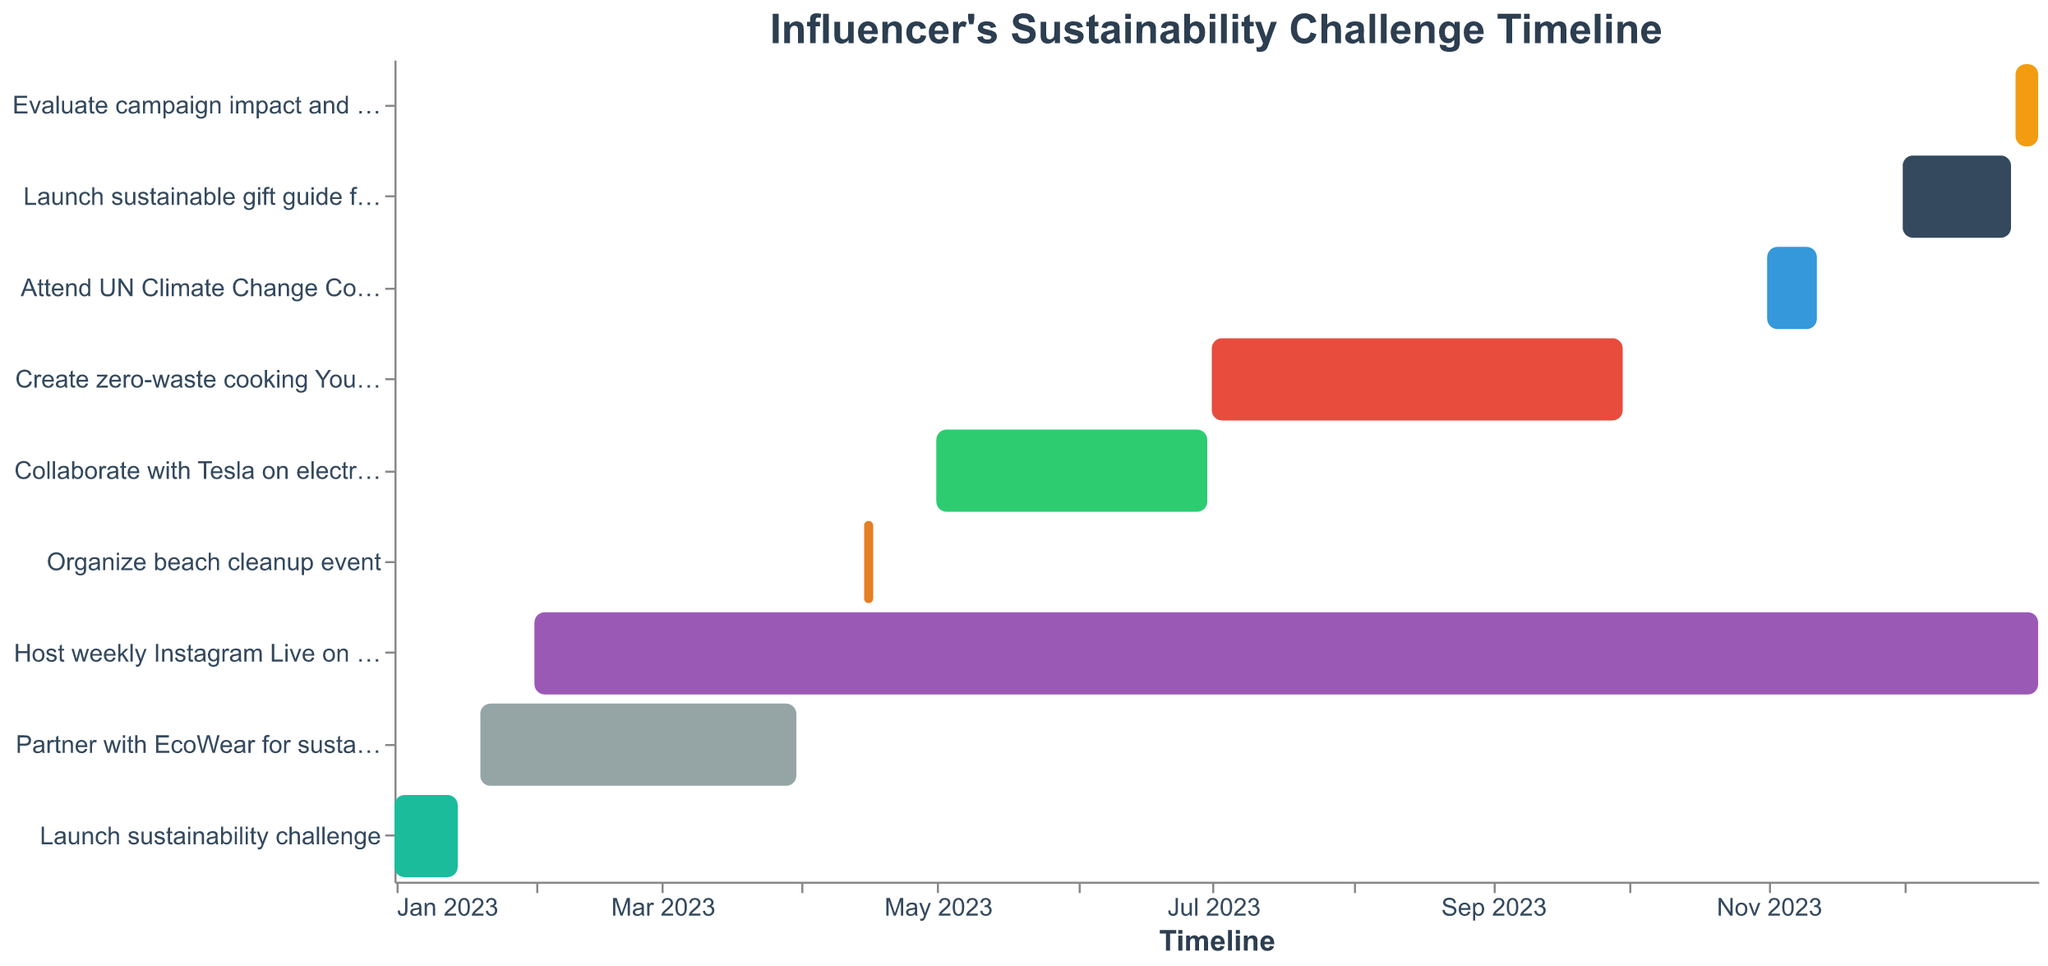What's the title of the Gantt Chart? The title is displayed at the top of the chart.
Answer: Influencer's Sustainability Challenge Timeline What is the duration for the partnership with EcoWear? The partnership with EcoWear starts on January 20, 2023, and ends on March 31, 2023.
Answer: 71 days Which task spans the longest duration? By comparing the start and end dates, the "Host weekly Instagram Live on eco-friendly tips" starts on February 1, 2023, and ends on December 31, 2023, making it the longest.
Answer: Host weekly Instagram Live on eco-friendly tips When does the beach cleanup event occur? The beach cleanup event is scheduled from April 15, 2023, to April 17, 2023.
Answer: April 15 to April 17, 2023 How many tasks are scheduled to begin in December 2023? By analyzing the start dates, two tasks, "Launch sustainable gift guide for holidays" and "Evaluate campaign impact and share results," start in December 2023.
Answer: 2 Which task is scheduled immediately after "Organize beach cleanup event"? The "Collaborate with Tesla on electric vehicle promotion" starts on May 1, 2023, right after the beach cleanup event ends on April 17, 2023.
Answer: Collaborate with Tesla on electric vehicle promotion What's the duration between the start of the sustainability challenge and the start of the sustainable gift guide for holidays? The sustainability challenge starts on January 1, 2023, and the sustainable gift guide for holidays starts on December 1, 2023. This results in an 11-month difference.
Answer: 11 months How long is the UN Climate Change Conference attended by the influencer? The conference starts on November 1, 2023, and ends on November 12, 2023.
Answer: 12 days Which tasks overlap with "Collaborate with Tesla on electric vehicle promotion"? "Host weekly Instagram Live on eco-friendly tips" (Feb 1 - Dec 31, 2023) overlaps with "Collaborate with Tesla on electric vehicle promotion" (May 1 - Jun 30, 2023).
Answer: Host weekly Instagram Live on eco-friendly tips What is the last task in the timeline and its duration? The last task is "Evaluate campaign impact and share results," scheduled from December 26, 2023, to December 31, 2023.
Answer: Evaluate campaign impact and share results, 6 days 